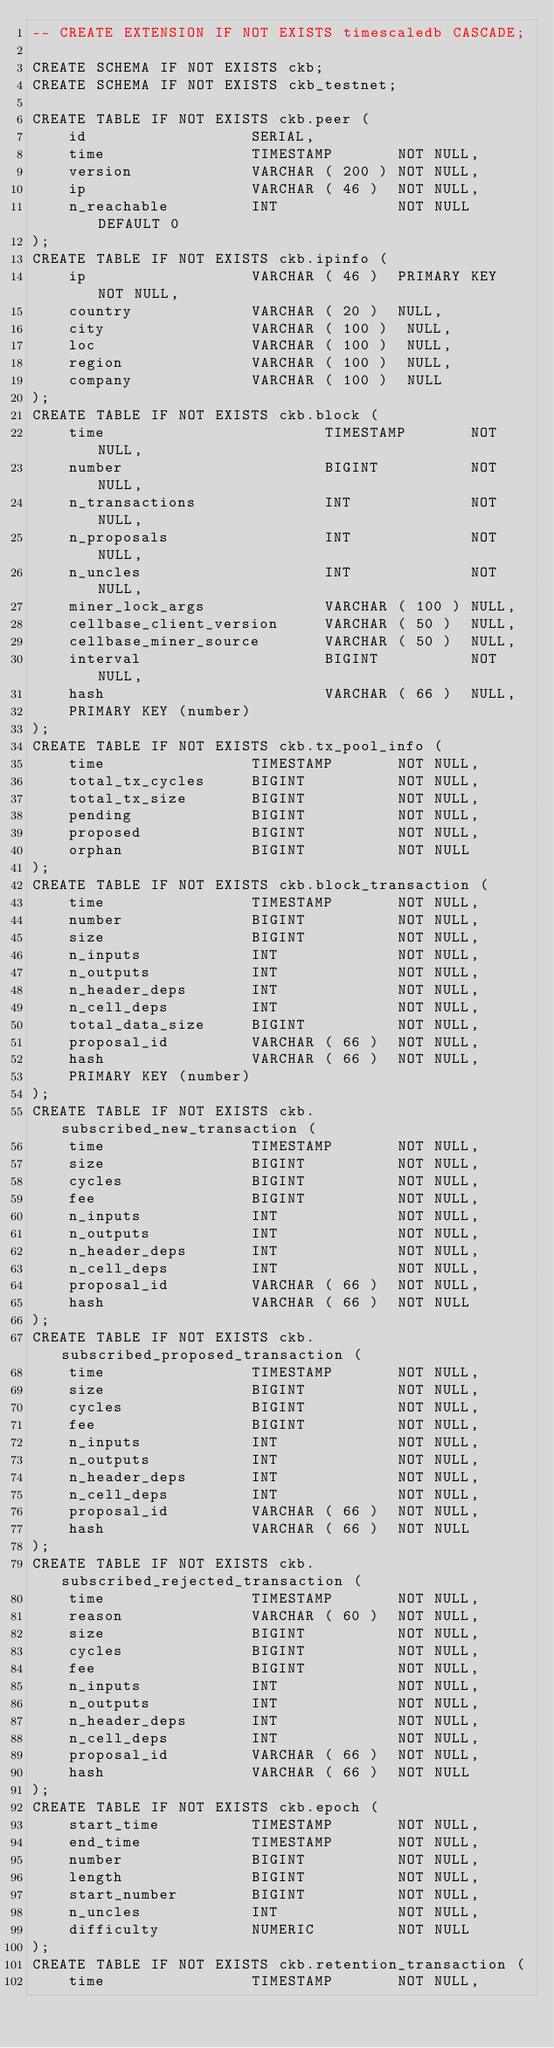Convert code to text. <code><loc_0><loc_0><loc_500><loc_500><_SQL_>-- CREATE EXTENSION IF NOT EXISTS timescaledb CASCADE;

CREATE SCHEMA IF NOT EXISTS ckb;
CREATE SCHEMA IF NOT EXISTS ckb_testnet;

CREATE TABLE IF NOT EXISTS ckb.peer (
    id                  SERIAL,
    time                TIMESTAMP       NOT NULL,
    version             VARCHAR ( 200 ) NOT NULL,
    ip                  VARCHAR ( 46 )  NOT NULL,
    n_reachable         INT             NOT NULL DEFAULT 0
);
CREATE TABLE IF NOT EXISTS ckb.ipinfo (
    ip                  VARCHAR ( 46 )  PRIMARY KEY NOT NULL,
    country             VARCHAR ( 20 )  NULL,
    city                VARCHAR ( 100 )  NULL,
    loc                 VARCHAR ( 100 )  NULL,
    region              VARCHAR ( 100 )  NULL,
    company             VARCHAR ( 100 )  NULL
);
CREATE TABLE IF NOT EXISTS ckb.block (
    time                        TIMESTAMP       NOT NULL,
    number                      BIGINT          NOT NULL,
    n_transactions              INT             NOT NULL,
    n_proposals                 INT             NOT NULL,
    n_uncles                    INT             NOT NULL,
    miner_lock_args             VARCHAR ( 100 ) NULL,
    cellbase_client_version     VARCHAR ( 50 )  NULL,
    cellbase_miner_source       VARCHAR ( 50 )  NULL,
    interval                    BIGINT          NOT NULL,
    hash                        VARCHAR ( 66 )  NULL,
    PRIMARY KEY (number)
);
CREATE TABLE IF NOT EXISTS ckb.tx_pool_info (
    time                TIMESTAMP       NOT NULL,
    total_tx_cycles     BIGINT          NOT NULL,
    total_tx_size       BIGINT          NOT NULL,
    pending             BIGINT          NOT NULL,
    proposed            BIGINT          NOT NULL,
    orphan              BIGINT          NOT NULL
);
CREATE TABLE IF NOT EXISTS ckb.block_transaction (
    time                TIMESTAMP       NOT NULL,
    number              BIGINT          NOT NULL,
    size                BIGINT          NOT NULL,
    n_inputs            INT             NOT NULL,
    n_outputs           INT             NOT NULL,
    n_header_deps       INT             NOT NULL,
    n_cell_deps         INT             NOT NULL,
    total_data_size     BIGINT          NOT NULL,
    proposal_id         VARCHAR ( 66 )  NOT NULL,
    hash                VARCHAR ( 66 )  NOT NULL,
    PRIMARY KEY (number)
);
CREATE TABLE IF NOT EXISTS ckb.subscribed_new_transaction (
    time                TIMESTAMP       NOT NULL,
    size                BIGINT          NOT NULL,
    cycles              BIGINT          NOT NULL,
    fee                 BIGINT          NOT NULL,
    n_inputs            INT             NOT NULL,
    n_outputs           INT             NOT NULL,
    n_header_deps       INT             NOT NULL,
    n_cell_deps         INT             NOT NULL,
    proposal_id         VARCHAR ( 66 )  NOT NULL,
    hash                VARCHAR ( 66 )  NOT NULL
);
CREATE TABLE IF NOT EXISTS ckb.subscribed_proposed_transaction (
    time                TIMESTAMP       NOT NULL,
    size                BIGINT          NOT NULL,
    cycles              BIGINT          NOT NULL,
    fee                 BIGINT          NOT NULL,
    n_inputs            INT             NOT NULL,
    n_outputs           INT             NOT NULL,
    n_header_deps       INT             NOT NULL,
    n_cell_deps         INT             NOT NULL,
    proposal_id         VARCHAR ( 66 )  NOT NULL,
    hash                VARCHAR ( 66 )  NOT NULL
);
CREATE TABLE IF NOT EXISTS ckb.subscribed_rejected_transaction (
    time                TIMESTAMP       NOT NULL,
    reason              VARCHAR ( 60 )  NOT NULL,
    size                BIGINT          NOT NULL,
    cycles              BIGINT          NOT NULL,
    fee                 BIGINT          NOT NULL,
    n_inputs            INT             NOT NULL,
    n_outputs           INT             NOT NULL,
    n_header_deps       INT             NOT NULL,
    n_cell_deps         INT             NOT NULL,
    proposal_id         VARCHAR ( 66 )  NOT NULL,
    hash                VARCHAR ( 66 )  NOT NULL
);
CREATE TABLE IF NOT EXISTS ckb.epoch (
    start_time          TIMESTAMP       NOT NULL,
    end_time            TIMESTAMP       NOT NULL,
    number              BIGINT          NOT NULL,
    length              BIGINT          NOT NULL,
    start_number        BIGINT          NOT NULL,
    n_uncles            INT             NOT NULL,
    difficulty          NUMERIC         NOT NULL
);
CREATE TABLE IF NOT EXISTS ckb.retention_transaction (
    time                TIMESTAMP       NOT NULL,</code> 